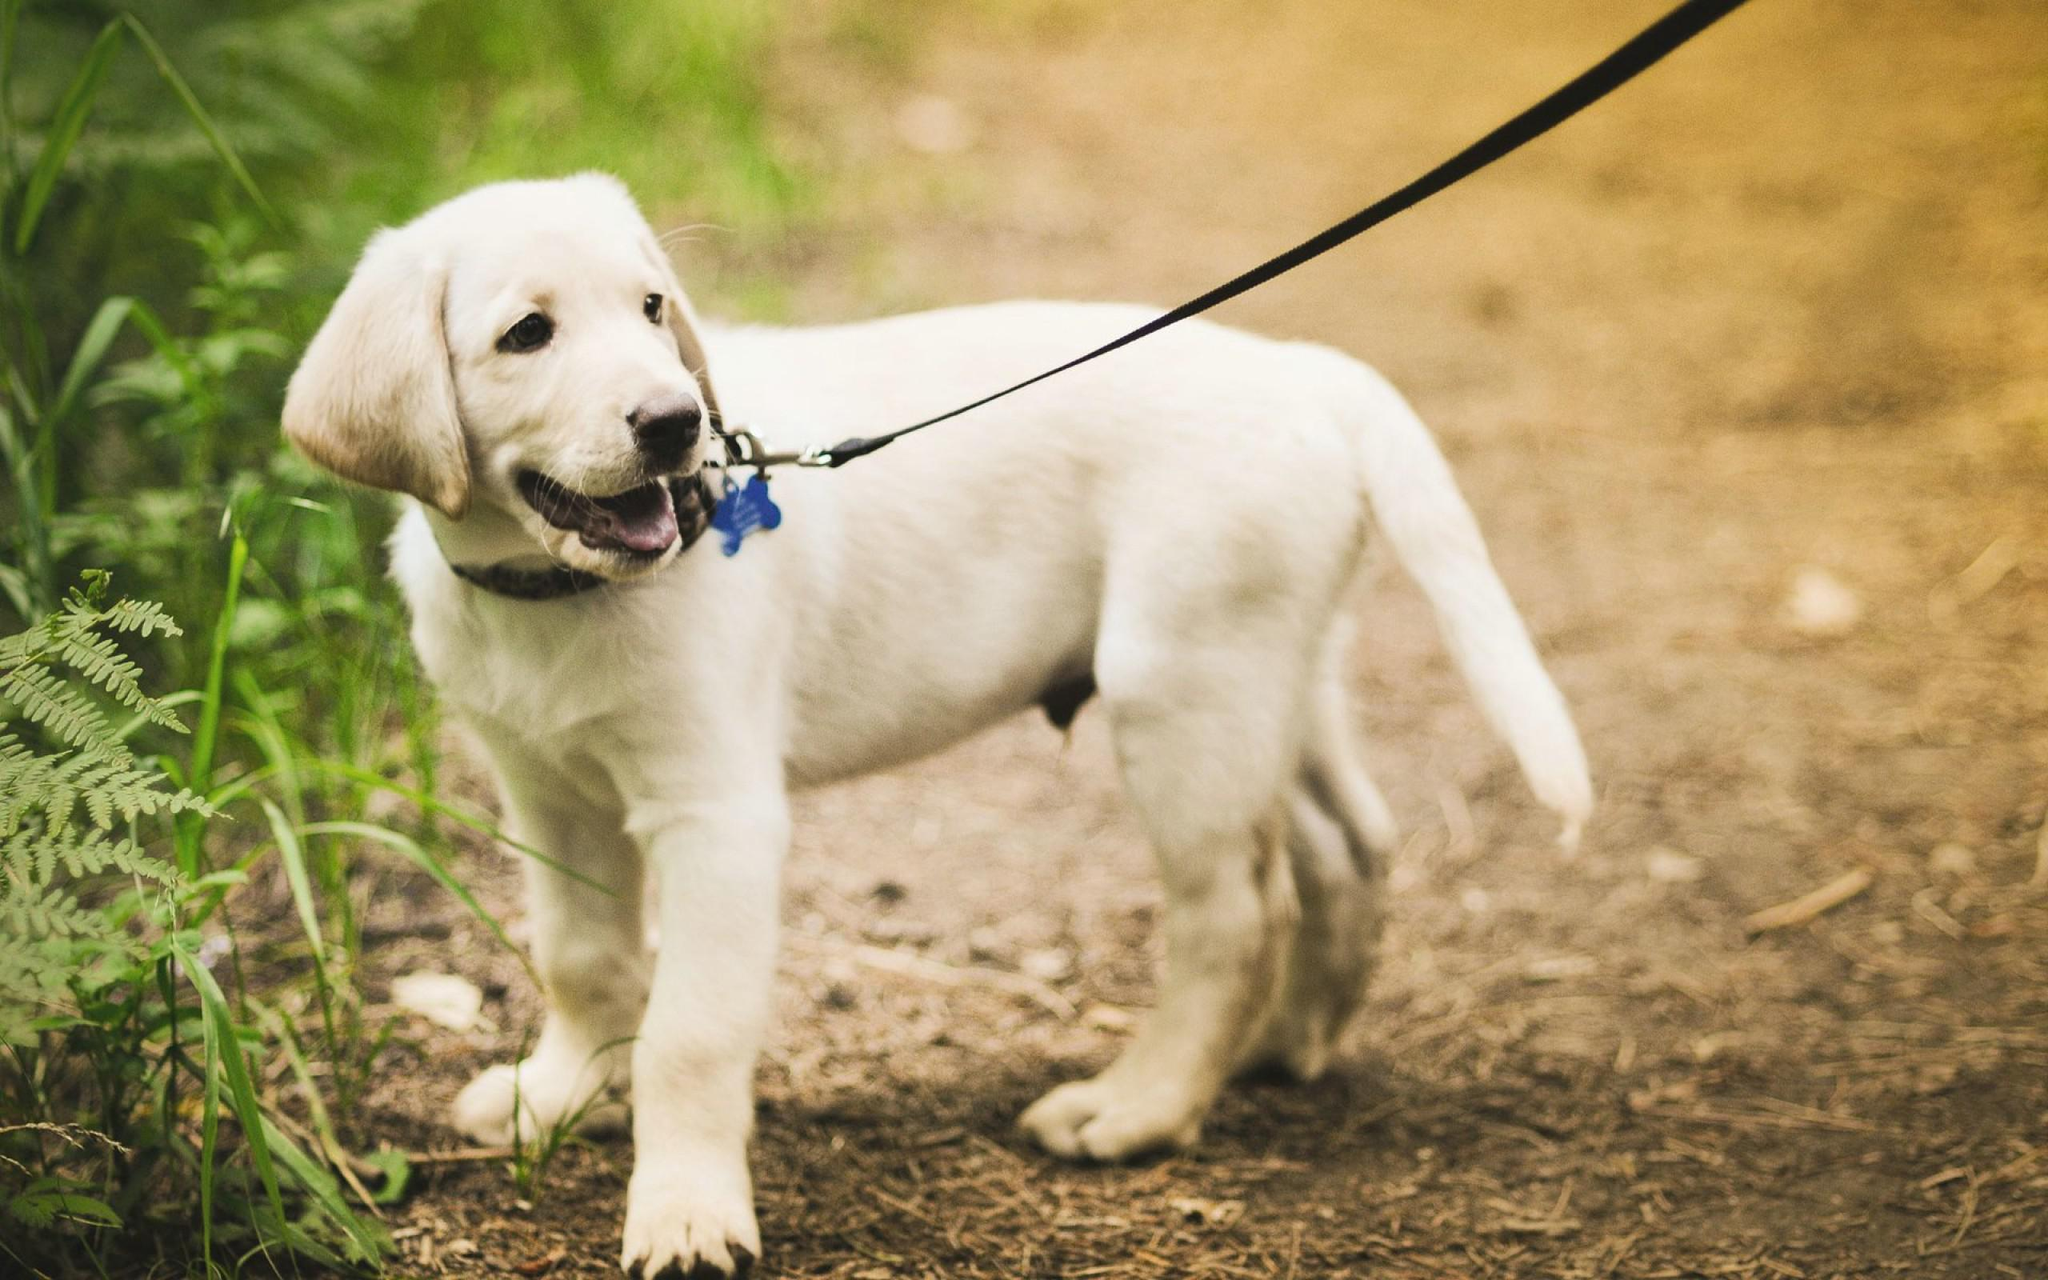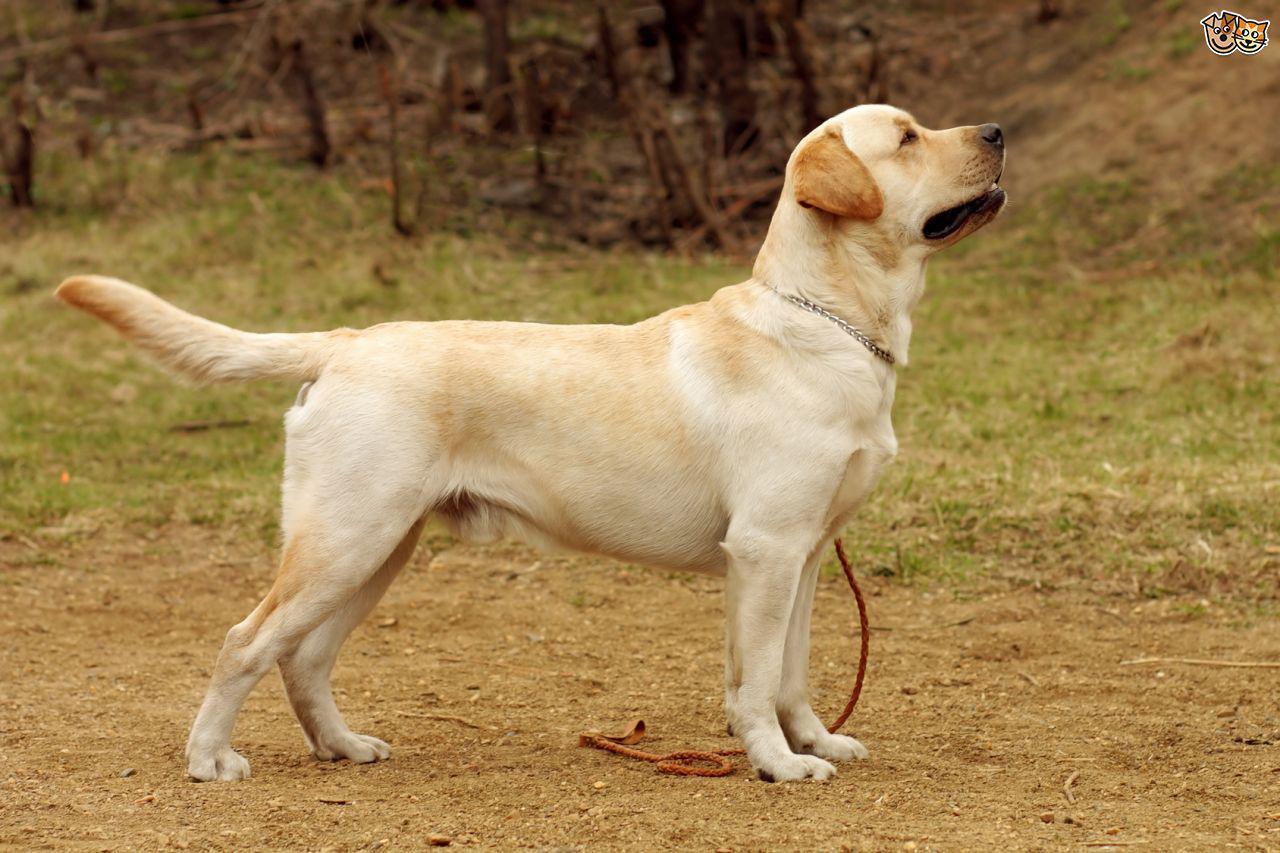The first image is the image on the left, the second image is the image on the right. For the images displayed, is the sentence "In 1 of the images, a dog is standing on grass." factually correct? Answer yes or no. No. 